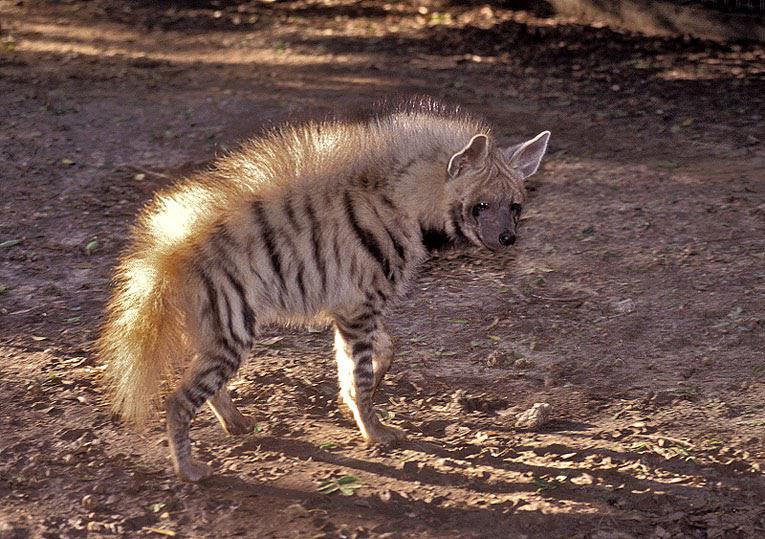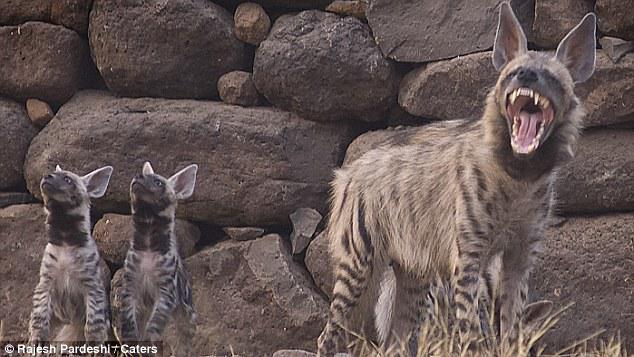The first image is the image on the left, the second image is the image on the right. Given the left and right images, does the statement "One of the animals on the right is baring its teeth." hold true? Answer yes or no. Yes. The first image is the image on the left, the second image is the image on the right. For the images displayed, is the sentence "An image shows only an upright hyena with erect hair running the length of its body." factually correct? Answer yes or no. Yes. 